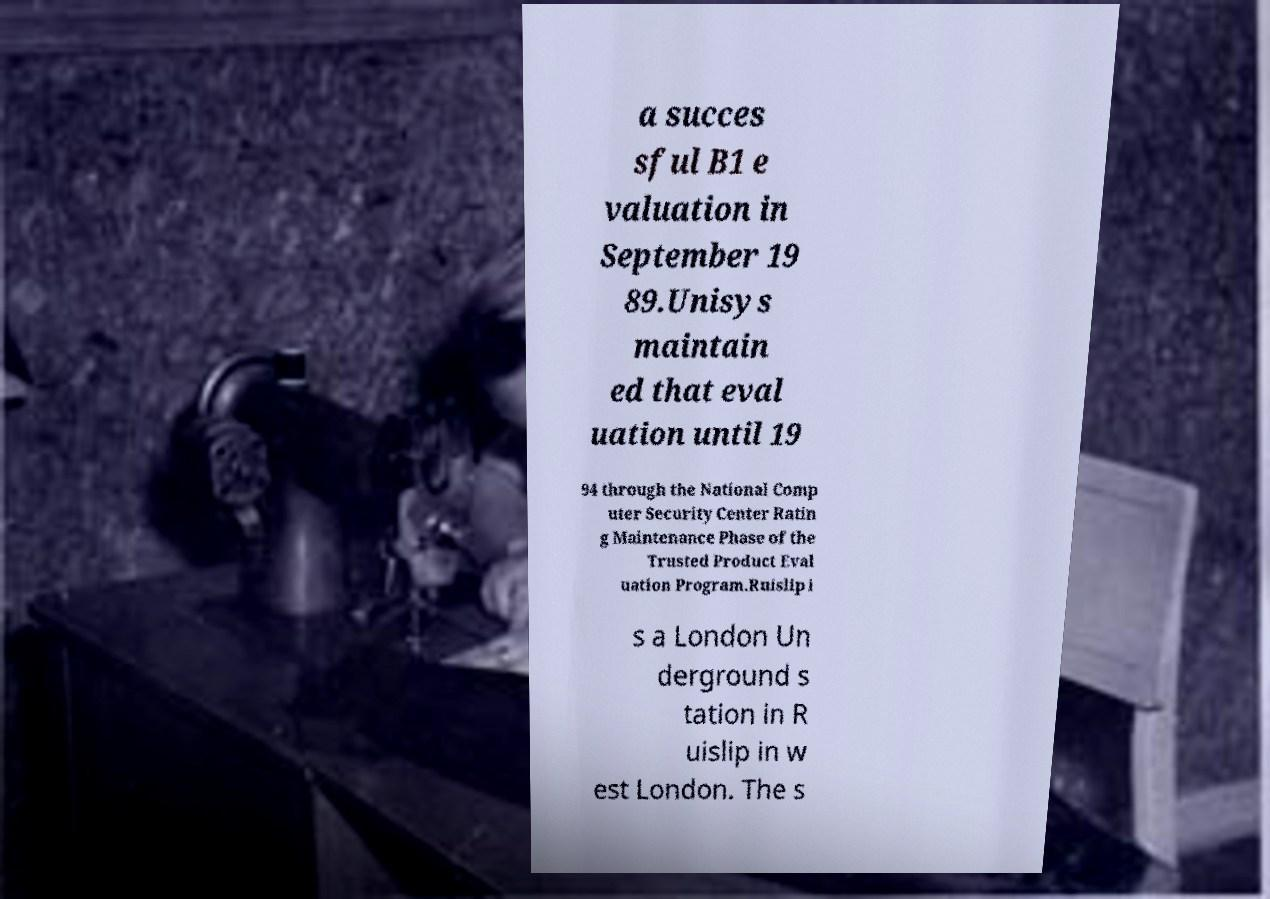For documentation purposes, I need the text within this image transcribed. Could you provide that? a succes sful B1 e valuation in September 19 89.Unisys maintain ed that eval uation until 19 94 through the National Comp uter Security Center Ratin g Maintenance Phase of the Trusted Product Eval uation Program.Ruislip i s a London Un derground s tation in R uislip in w est London. The s 